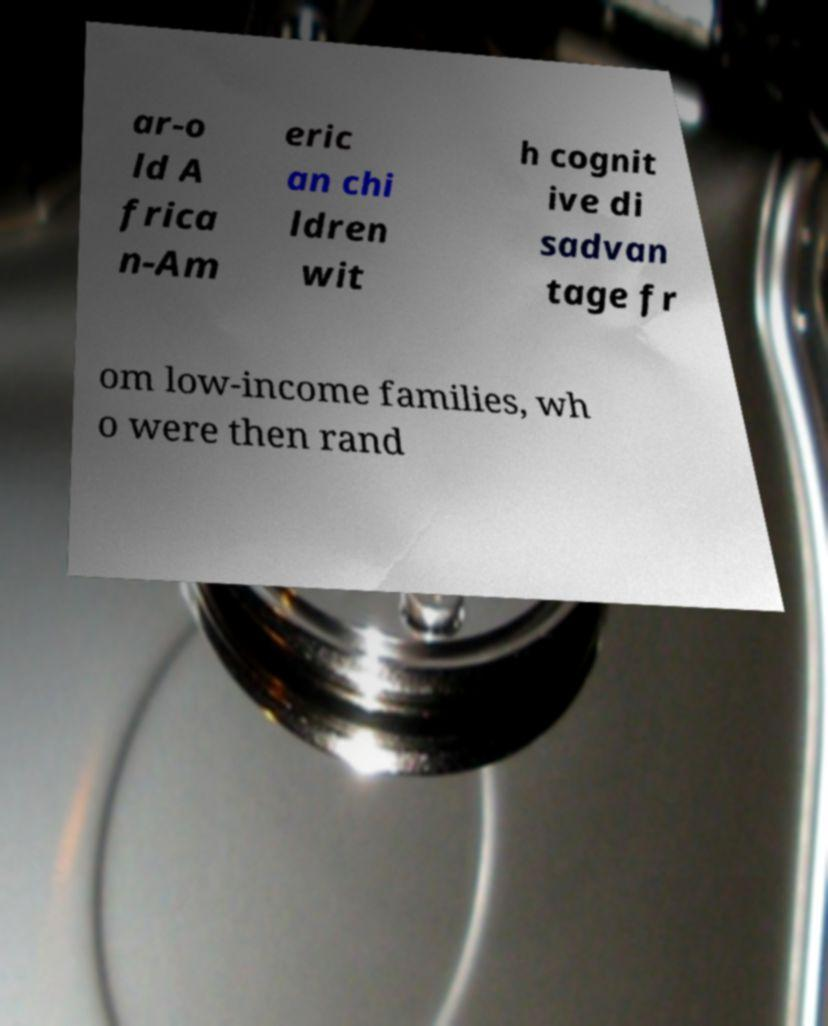Can you accurately transcribe the text from the provided image for me? ar-o ld A frica n-Am eric an chi ldren wit h cognit ive di sadvan tage fr om low-income families, wh o were then rand 